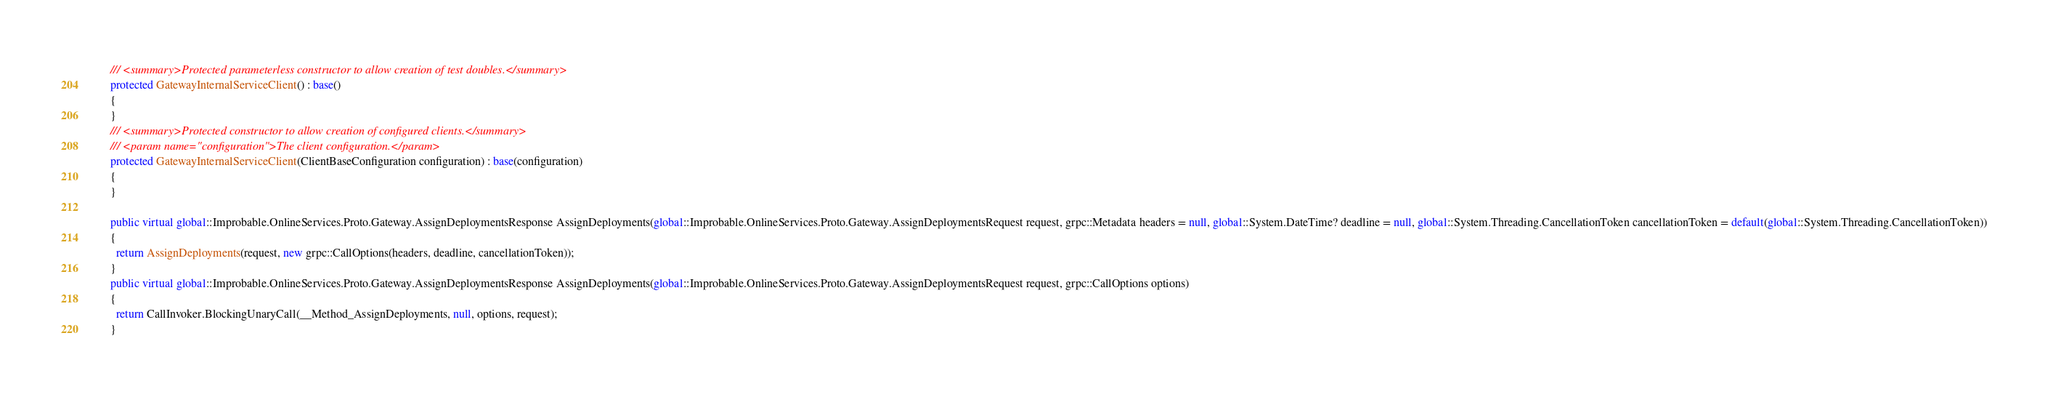<code> <loc_0><loc_0><loc_500><loc_500><_C#_>      /// <summary>Protected parameterless constructor to allow creation of test doubles.</summary>
      protected GatewayInternalServiceClient() : base()
      {
      }
      /// <summary>Protected constructor to allow creation of configured clients.</summary>
      /// <param name="configuration">The client configuration.</param>
      protected GatewayInternalServiceClient(ClientBaseConfiguration configuration) : base(configuration)
      {
      }

      public virtual global::Improbable.OnlineServices.Proto.Gateway.AssignDeploymentsResponse AssignDeployments(global::Improbable.OnlineServices.Proto.Gateway.AssignDeploymentsRequest request, grpc::Metadata headers = null, global::System.DateTime? deadline = null, global::System.Threading.CancellationToken cancellationToken = default(global::System.Threading.CancellationToken))
      {
        return AssignDeployments(request, new grpc::CallOptions(headers, deadline, cancellationToken));
      }
      public virtual global::Improbable.OnlineServices.Proto.Gateway.AssignDeploymentsResponse AssignDeployments(global::Improbable.OnlineServices.Proto.Gateway.AssignDeploymentsRequest request, grpc::CallOptions options)
      {
        return CallInvoker.BlockingUnaryCall(__Method_AssignDeployments, null, options, request);
      }</code> 